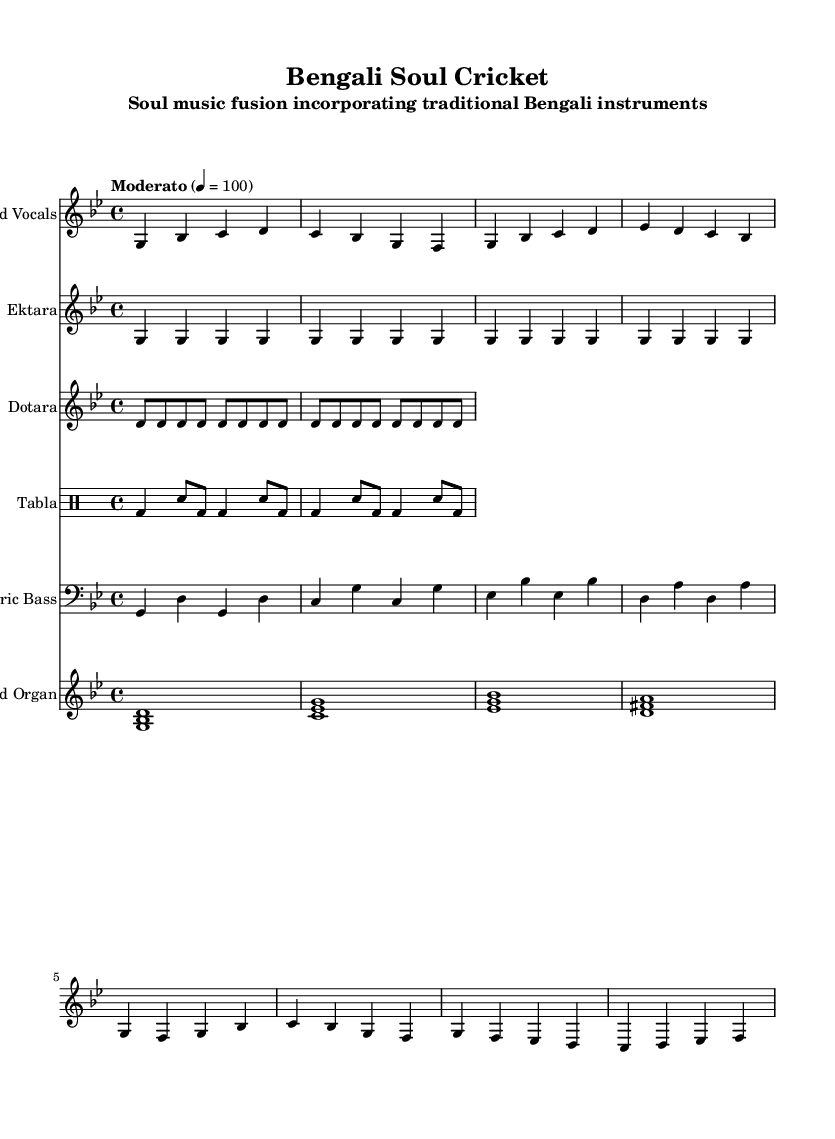What is the key signature of this music? The key signature is indicated at the beginning of the sheet music and shows two flats, which means it is B flat major or G minor.
Answer: G minor What is the time signature of the piece? The time signature is specified next to the key signature at the beginning of the sheet music, showing that there are four beats per measure.
Answer: 4/4 What is the tempo marking provided for this music? The tempo marking can be found in the global section; it indicates a moderato pace of 100 beats per minute.
Answer: Moderato 4 = 100 How many measures does the lead vocals part contain? By counting the individual measures of the lead vocals part from the provided sheet music, there are a total of eight measures.
Answer: 8 What instruments are featured in this composition? The names of the instruments are written above each staff; they include Lead Vocals, Ektara, Dotara, Tabla, Electric Bass, and Hammond Organ.
Answer: Lead Vocals, Ektara, Dotara, Tabla, Electric Bass, Hammond Organ Which instrument plays a repetitive pattern throughout the piece? The Ektara part is composed entirely of repeated notes, signifying a consistent pattern.
Answer: Ektara 